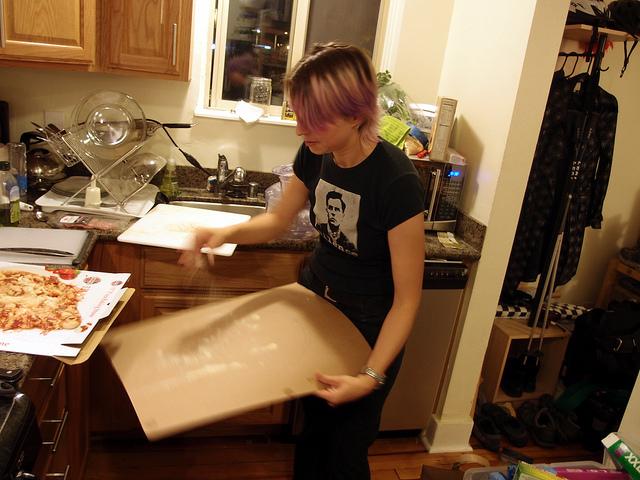What is she eating?
Quick response, please. Pizza. What is the brown thing the woman is holding?
Keep it brief. Cardboard. Is this kitchen in an apartment?
Answer briefly. Yes. What room is this person in?
Concise answer only. Kitchen. What is she cutting?
Write a very short answer. Pizza. Is this the kitchen of a restaurant?
Write a very short answer. No. 